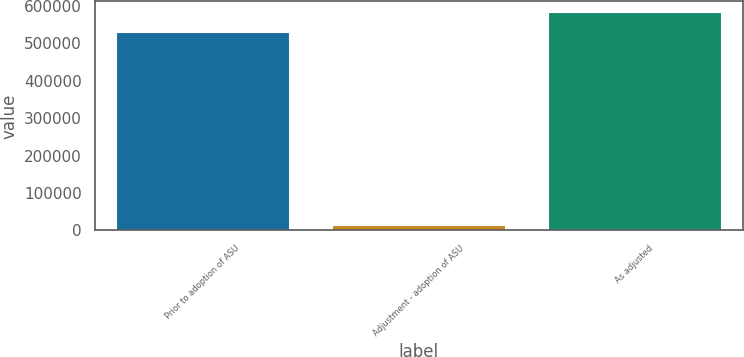<chart> <loc_0><loc_0><loc_500><loc_500><bar_chart><fcel>Prior to adoption of ASU<fcel>Adjustment - adoption of ASU<fcel>As adjusted<nl><fcel>529837<fcel>14445<fcel>582821<nl></chart> 